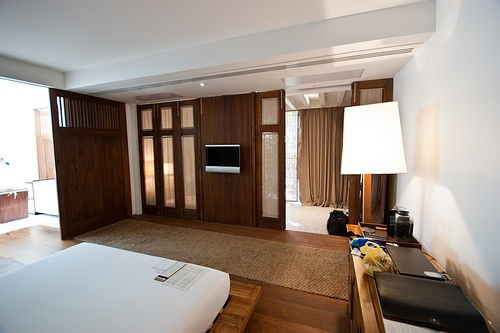Describe the objects in this image and their specific colors. I can see bed in gray, darkgray, and lightgray tones, laptop in gray, black, and maroon tones, laptop in gray, black, and maroon tones, and tv in gray, black, darkgray, and lightgray tones in this image. 